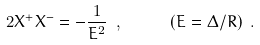Convert formula to latex. <formula><loc_0><loc_0><loc_500><loc_500>2 X ^ { + } X ^ { - } = - \frac { 1 } { E ^ { 2 } } \ , \quad \ \ ( E = \Delta / R ) \ .</formula> 